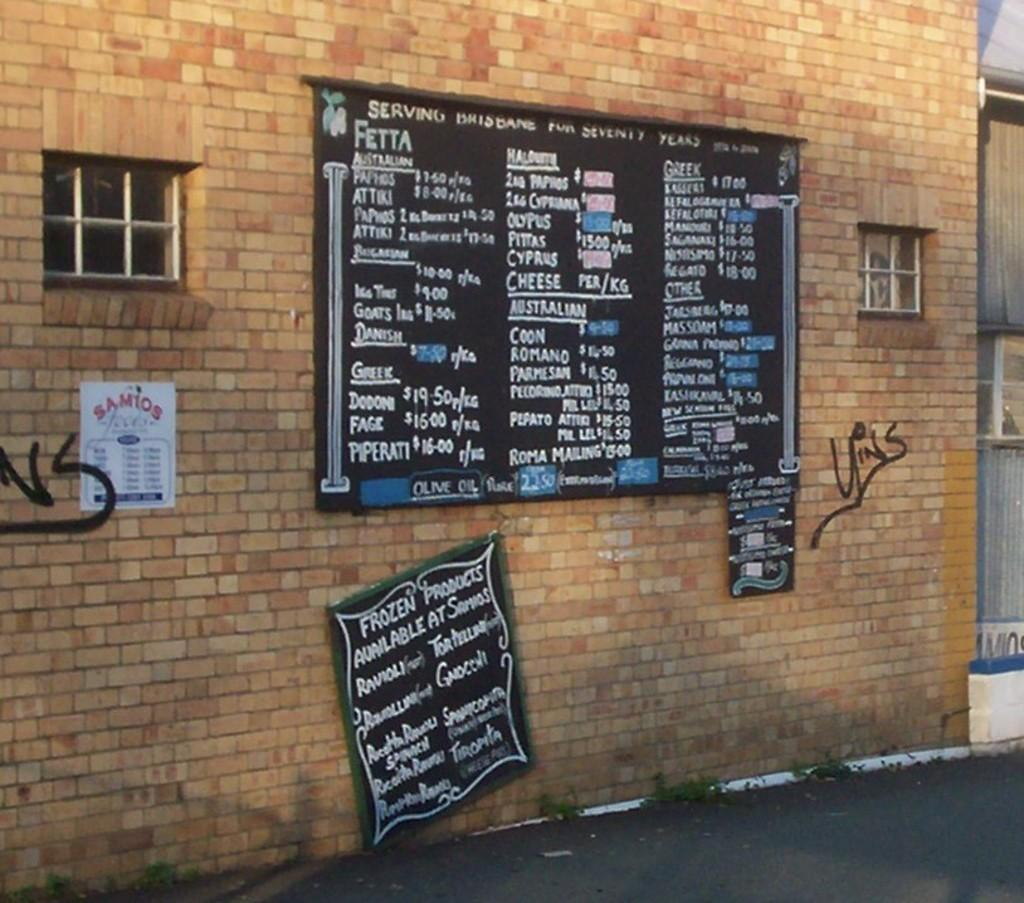What is covering the brick wall in the image? There is black paint on a brick wall in the image. What is written or drawn on the black paint? Text is written on the black paint. What other objects can be seen in the image? There are ventilators visible in the image. What type of nut is being hammered by the yak in the image? There is no yak or hammer present in the image, and therefore no such activity can be observed. 